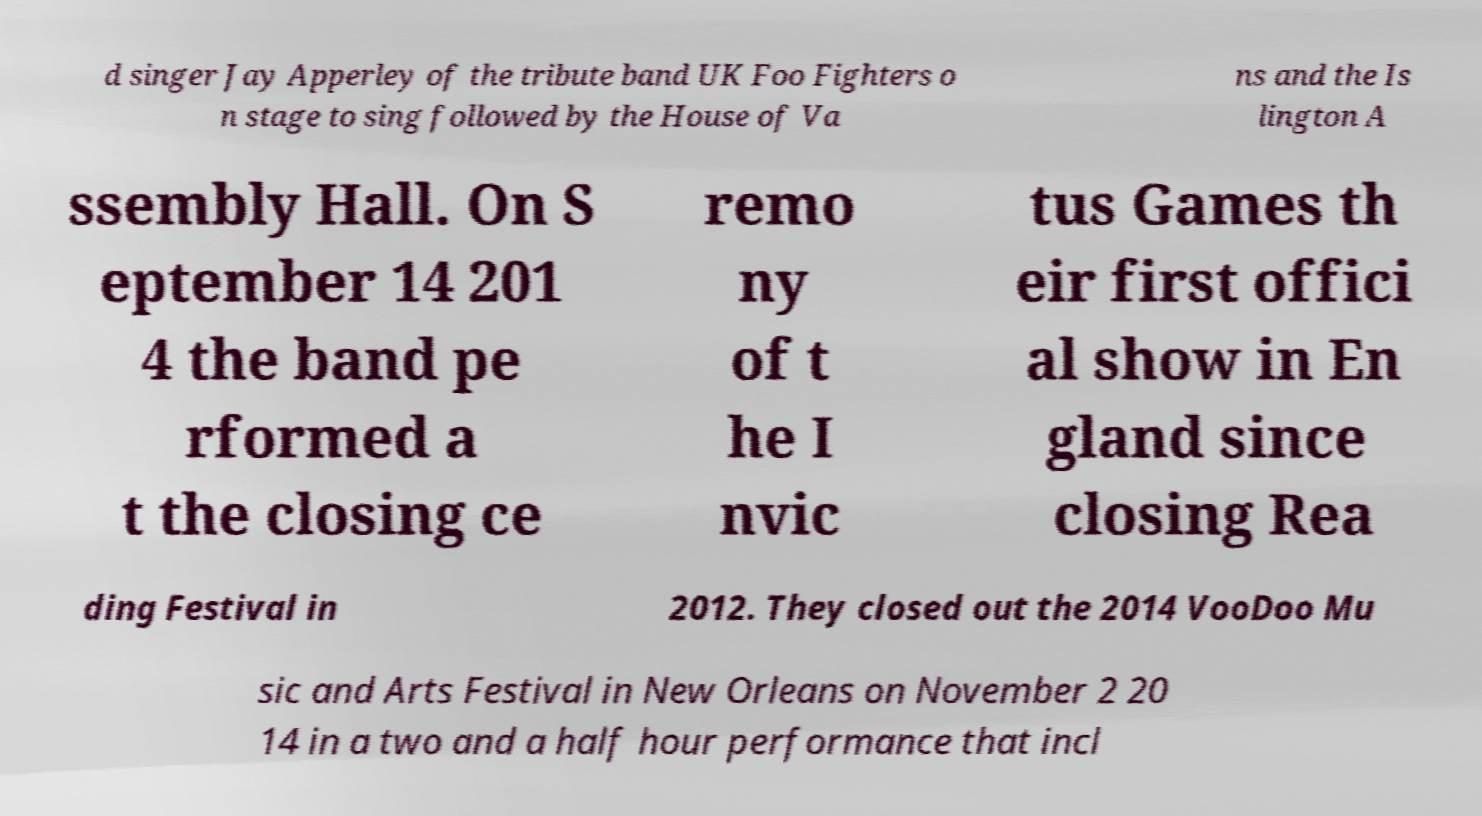Please identify and transcribe the text found in this image. d singer Jay Apperley of the tribute band UK Foo Fighters o n stage to sing followed by the House of Va ns and the Is lington A ssembly Hall. On S eptember 14 201 4 the band pe rformed a t the closing ce remo ny of t he I nvic tus Games th eir first offici al show in En gland since closing Rea ding Festival in 2012. They closed out the 2014 VooDoo Mu sic and Arts Festival in New Orleans on November 2 20 14 in a two and a half hour performance that incl 